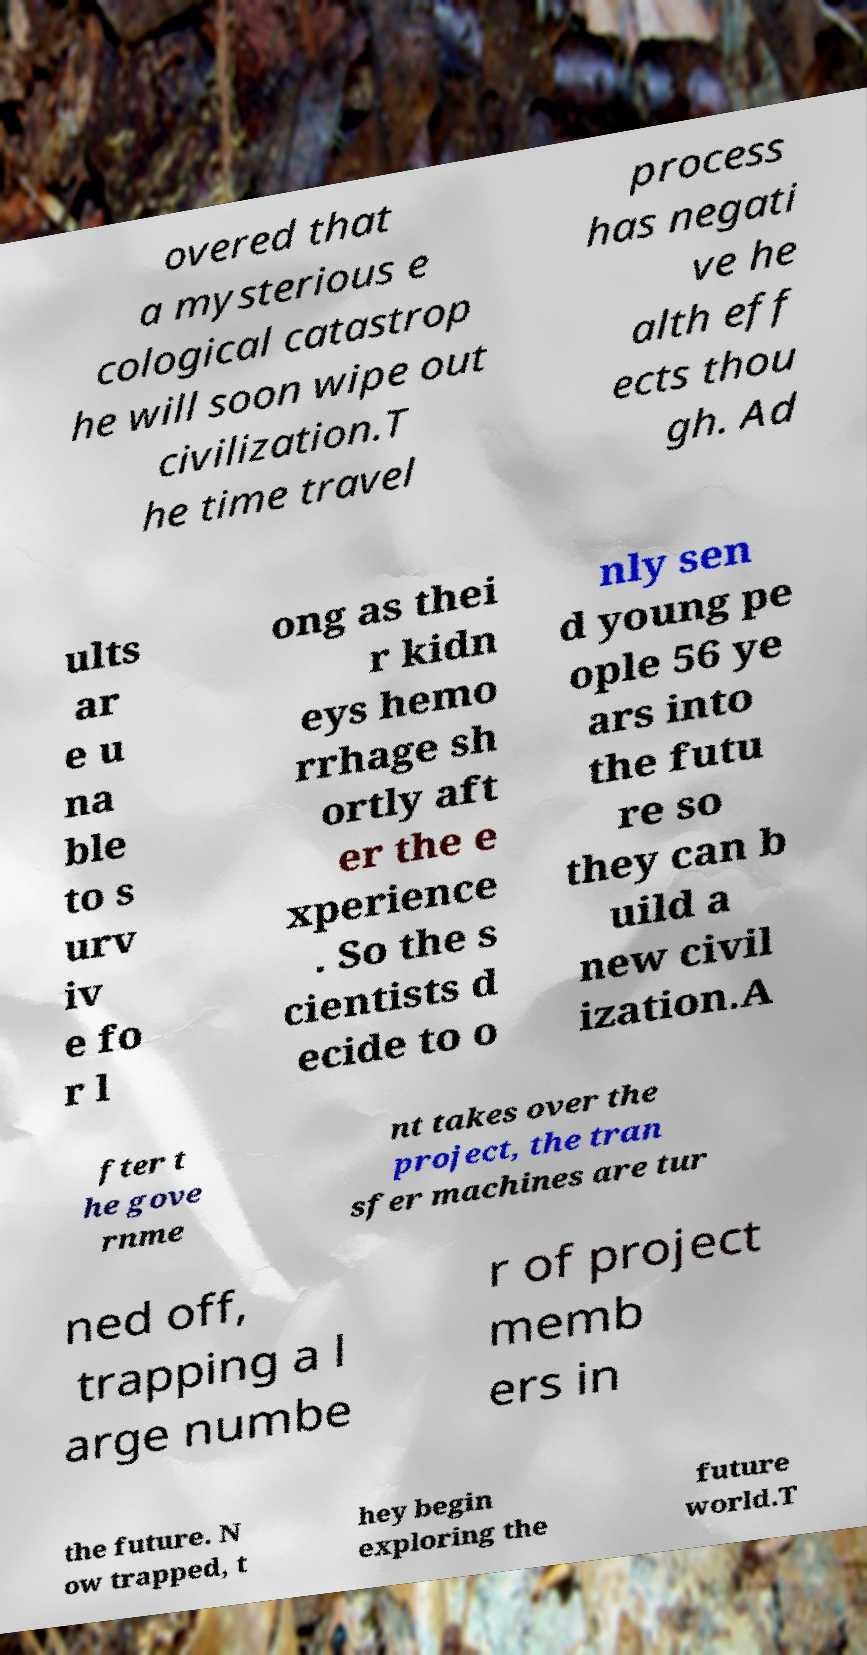Please read and relay the text visible in this image. What does it say? overed that a mysterious e cological catastrop he will soon wipe out civilization.T he time travel process has negati ve he alth eff ects thou gh. Ad ults ar e u na ble to s urv iv e fo r l ong as thei r kidn eys hemo rrhage sh ortly aft er the e xperience . So the s cientists d ecide to o nly sen d young pe ople 56 ye ars into the futu re so they can b uild a new civil ization.A fter t he gove rnme nt takes over the project, the tran sfer machines are tur ned off, trapping a l arge numbe r of project memb ers in the future. N ow trapped, t hey begin exploring the future world.T 